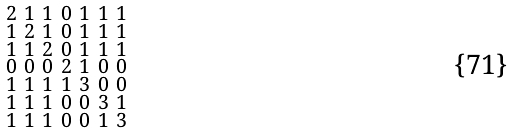<formula> <loc_0><loc_0><loc_500><loc_500>\begin{smallmatrix} 2 & 1 & 1 & 0 & 1 & 1 & 1 \\ 1 & 2 & 1 & 0 & 1 & 1 & 1 \\ 1 & 1 & 2 & 0 & 1 & 1 & 1 \\ 0 & 0 & 0 & 2 & 1 & 0 & 0 \\ 1 & 1 & 1 & 1 & 3 & 0 & 0 \\ 1 & 1 & 1 & 0 & 0 & 3 & 1 \\ 1 & 1 & 1 & 0 & 0 & 1 & 3 \end{smallmatrix}</formula> 